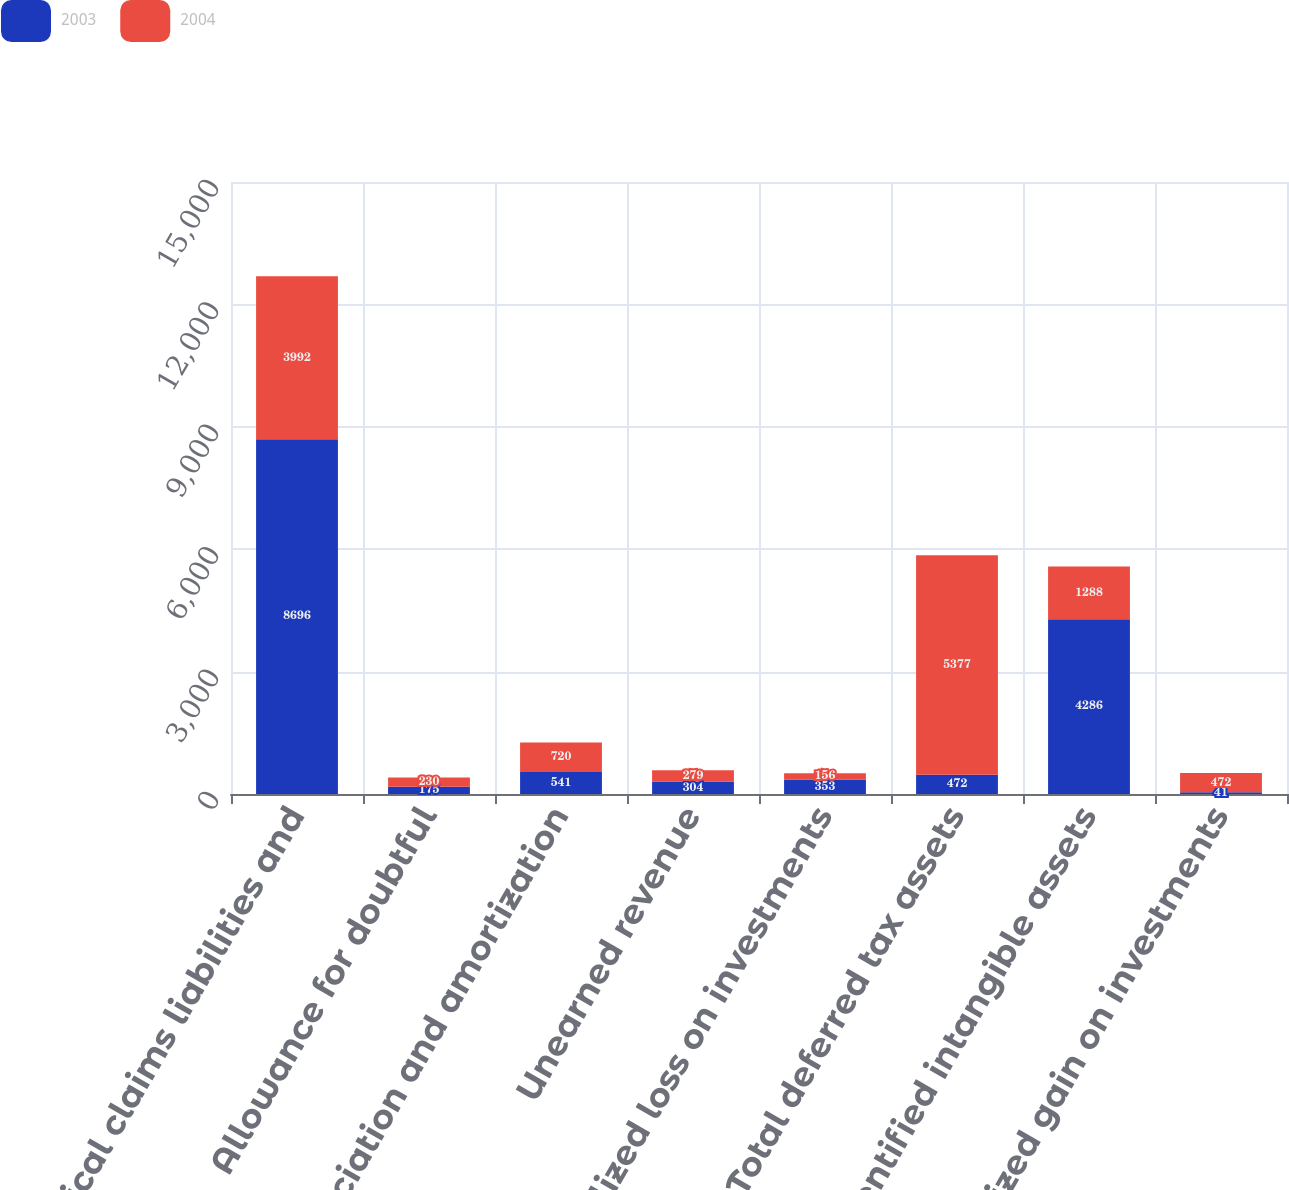<chart> <loc_0><loc_0><loc_500><loc_500><stacked_bar_chart><ecel><fcel>Medical claims liabilities and<fcel>Allowance for doubtful<fcel>Depreciation and amortization<fcel>Unearned revenue<fcel>Unrealized loss on investments<fcel>Total deferred tax assets<fcel>Identified intangible assets<fcel>Unrealized gain on investments<nl><fcel>2003<fcel>8696<fcel>175<fcel>541<fcel>304<fcel>353<fcel>472<fcel>4286<fcel>41<nl><fcel>2004<fcel>3992<fcel>230<fcel>720<fcel>279<fcel>156<fcel>5377<fcel>1288<fcel>472<nl></chart> 